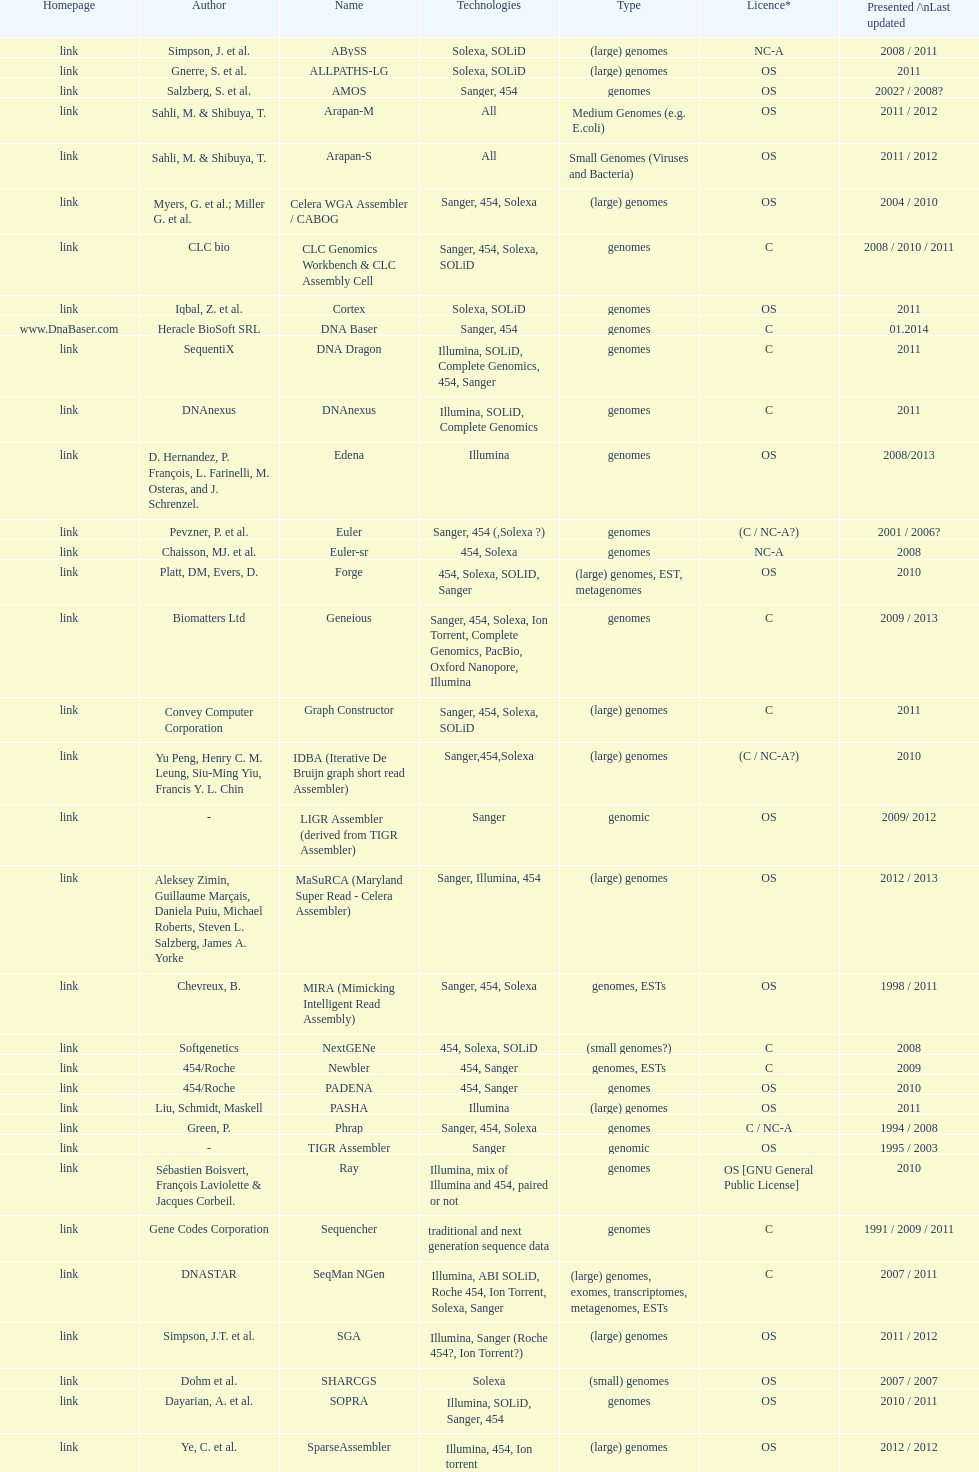How many are listed as "all" technologies? 2. 